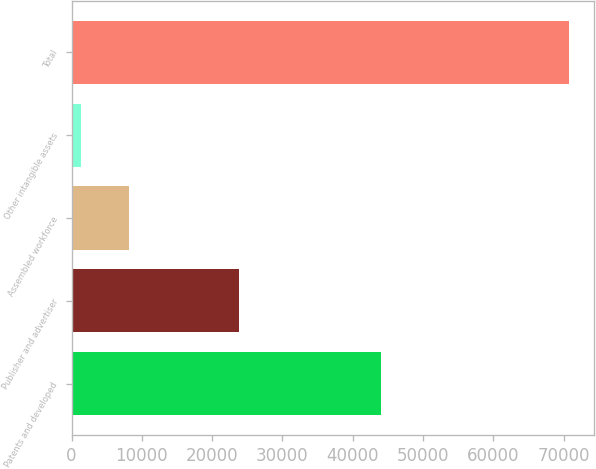Convert chart to OTSL. <chart><loc_0><loc_0><loc_500><loc_500><bar_chart><fcel>Patents and developed<fcel>Publisher and advertiser<fcel>Assembled workforce<fcel>Other intangible assets<fcel>Total<nl><fcel>43991<fcel>23803<fcel>8231.8<fcel>1281<fcel>70789<nl></chart> 